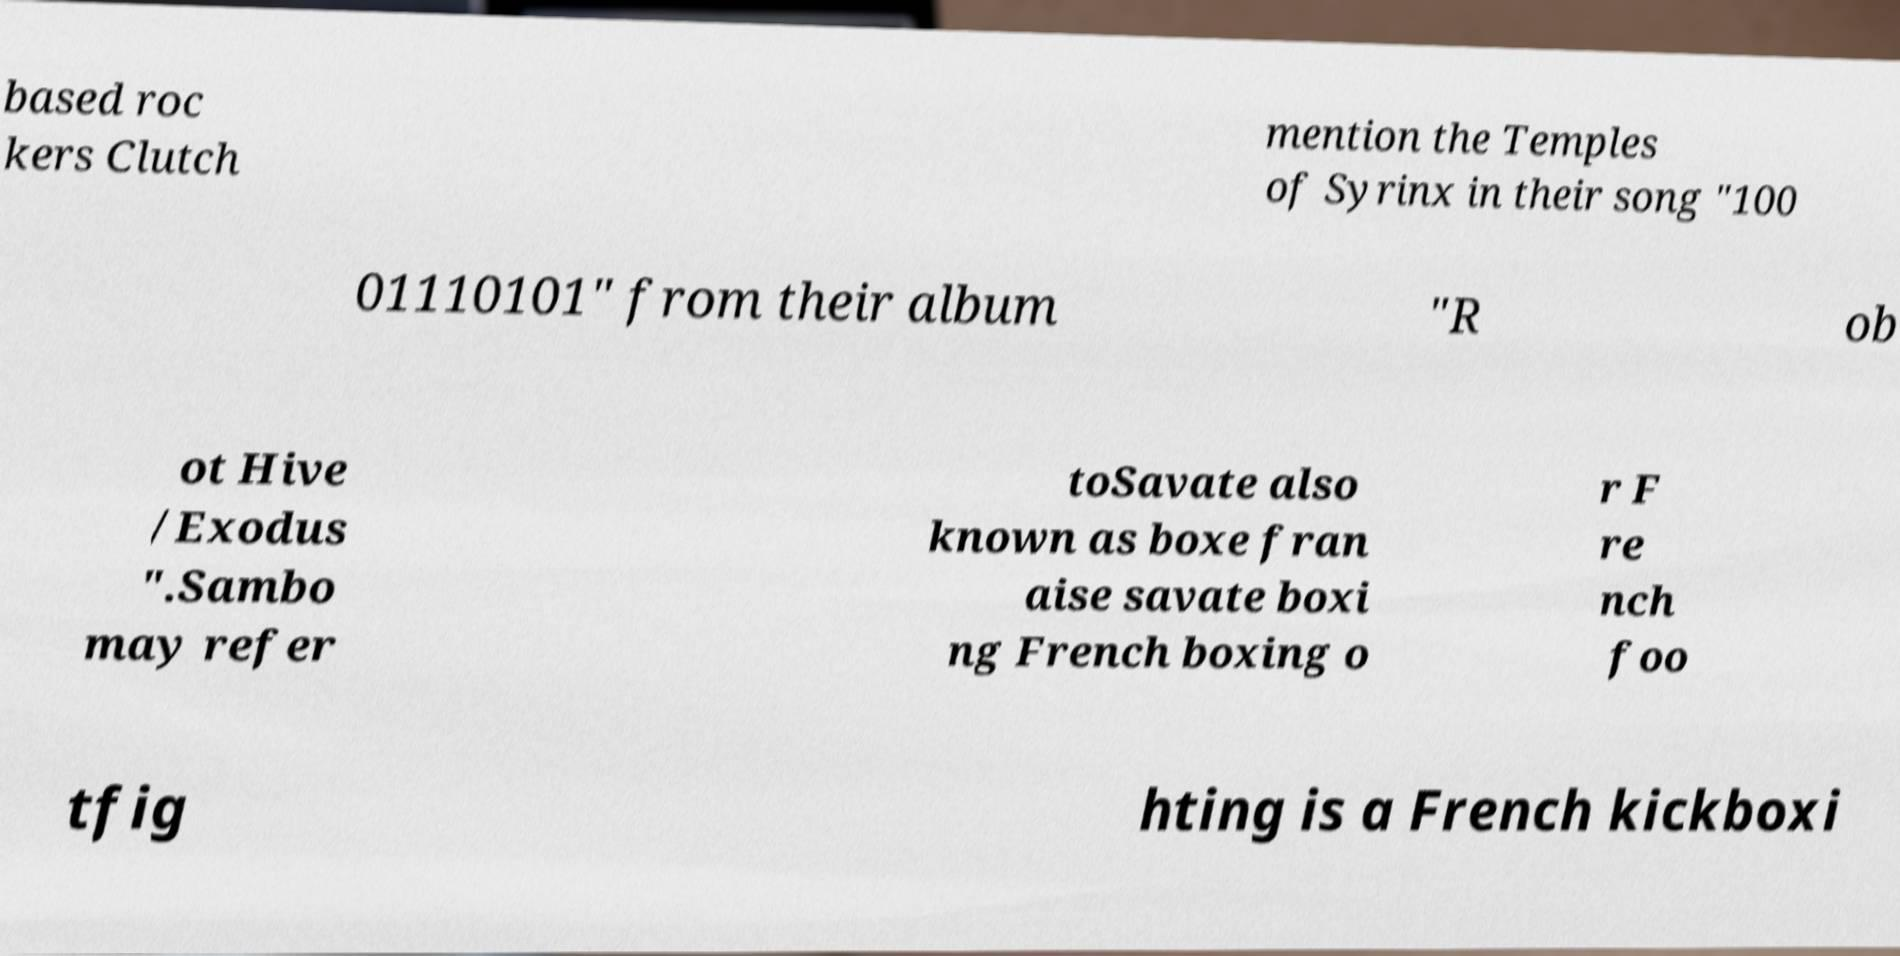Can you read and provide the text displayed in the image?This photo seems to have some interesting text. Can you extract and type it out for me? based roc kers Clutch mention the Temples of Syrinx in their song "100 01110101" from their album "R ob ot Hive /Exodus ".Sambo may refer toSavate also known as boxe fran aise savate boxi ng French boxing o r F re nch foo tfig hting is a French kickboxi 